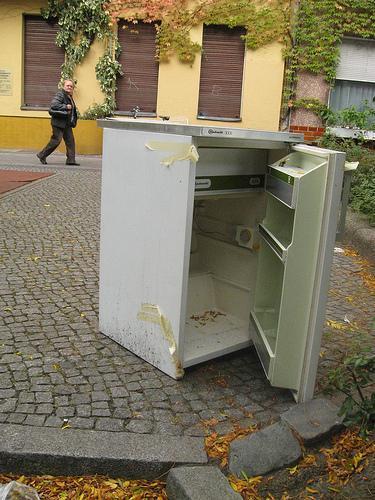How many green refrigerators are closed in the image?
Give a very brief answer. 0. 